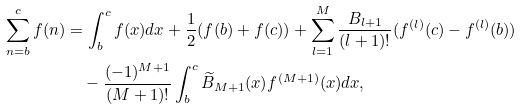Convert formula to latex. <formula><loc_0><loc_0><loc_500><loc_500>\sum ^ { c } _ { n = b } f ( n ) & = \int ^ { c } _ { b } f ( x ) d x + \frac { 1 } { 2 } ( f ( b ) + f ( c ) ) + \sum ^ { M } _ { l = 1 } \frac { B _ { l + 1 } } { ( l + 1 ) ! } ( f ^ { ( l ) } ( c ) - f ^ { ( l ) } ( b ) ) \\ & \quad - \frac { ( - 1 ) ^ { M + 1 } } { ( M + 1 ) ! } \int ^ { c } _ { b } \widetilde { B } _ { M + 1 } ( x ) f ^ { ( M + 1 ) } ( x ) d x ,</formula> 